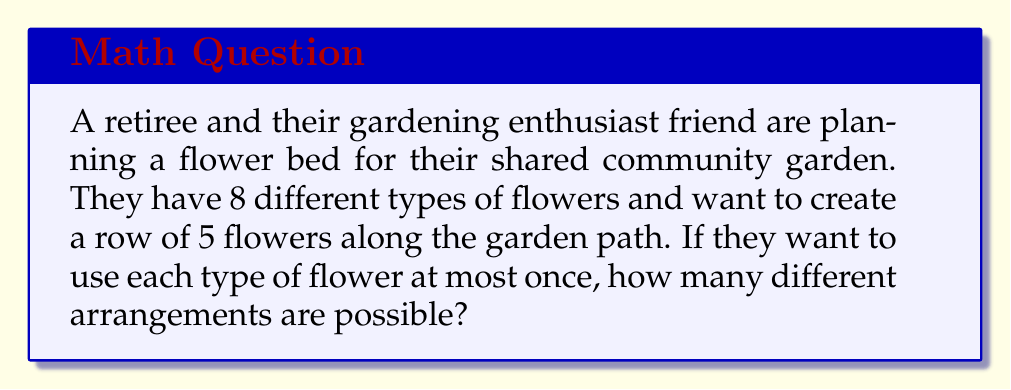Could you help me with this problem? Let's approach this step-by-step:

1) This is a permutation problem. We are selecting 5 flowers out of 8 types, and the order matters (it's an arrangement).

2) The formula for permutations without repetition is:

   $$P(n,r) = \frac{n!}{(n-r)!}$$

   Where $n$ is the total number of items to choose from, and $r$ is the number of items being chosen.

3) In this case:
   $n = 8$ (total types of flowers)
   $r = 5$ (flowers in each arrangement)

4) Plugging these values into our formula:

   $$P(8,5) = \frac{8!}{(8-5)!} = \frac{8!}{3!}$$

5) Let's calculate this:
   
   $$\frac{8!}{3!} = \frac{8 \times 7 \times 6 \times 5 \times 4 \times 3!}{3!}$$

6) The $3!$ cancels out in the numerator and denominator:

   $$8 \times 7 \times 6 \times 5 \times 4 = 6720$$

Therefore, there are 6720 different possible arrangements of 5 flowers chosen from 8 types.
Answer: 6720 possible arrangements 